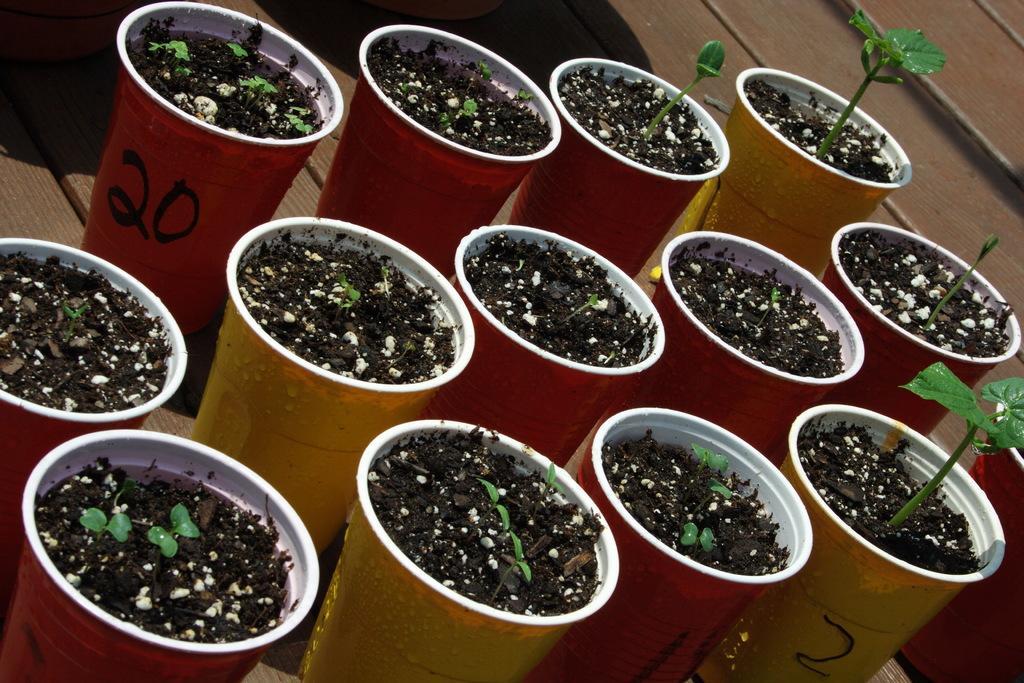In one or two sentences, can you explain what this image depicts? In this image we can see some flower pots which are of different colors like red and yellow in which there is mud are on the wooden surface. 